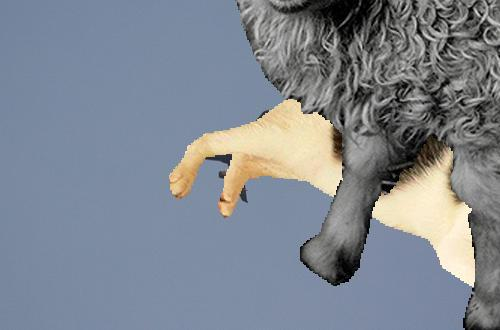How many unicorns are there in the image? 0 